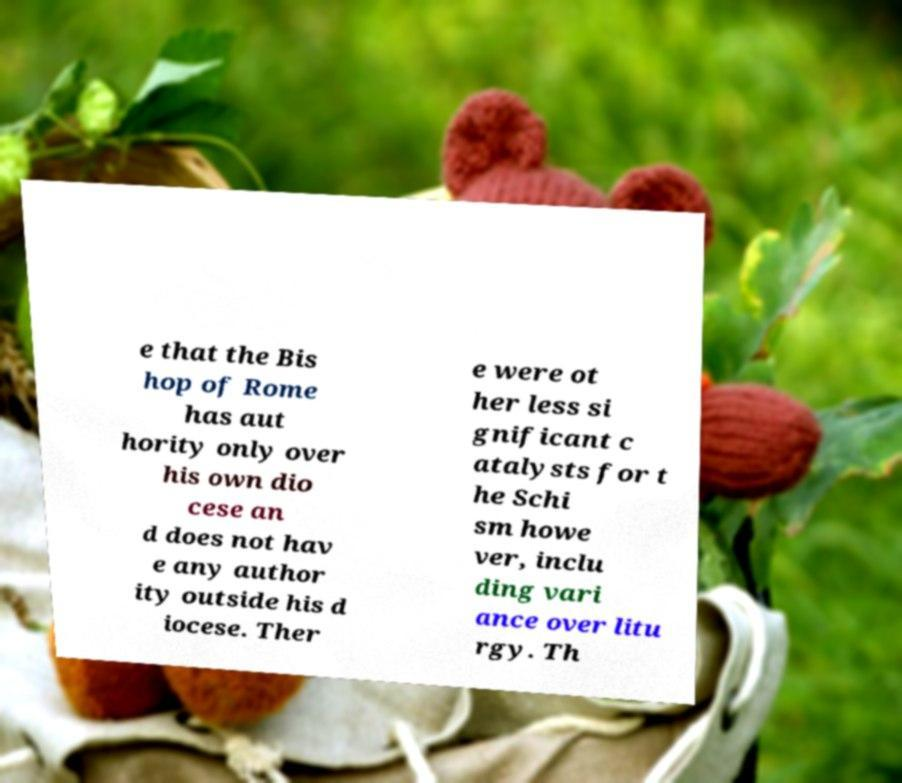Can you read and provide the text displayed in the image?This photo seems to have some interesting text. Can you extract and type it out for me? e that the Bis hop of Rome has aut hority only over his own dio cese an d does not hav e any author ity outside his d iocese. Ther e were ot her less si gnificant c atalysts for t he Schi sm howe ver, inclu ding vari ance over litu rgy. Th 